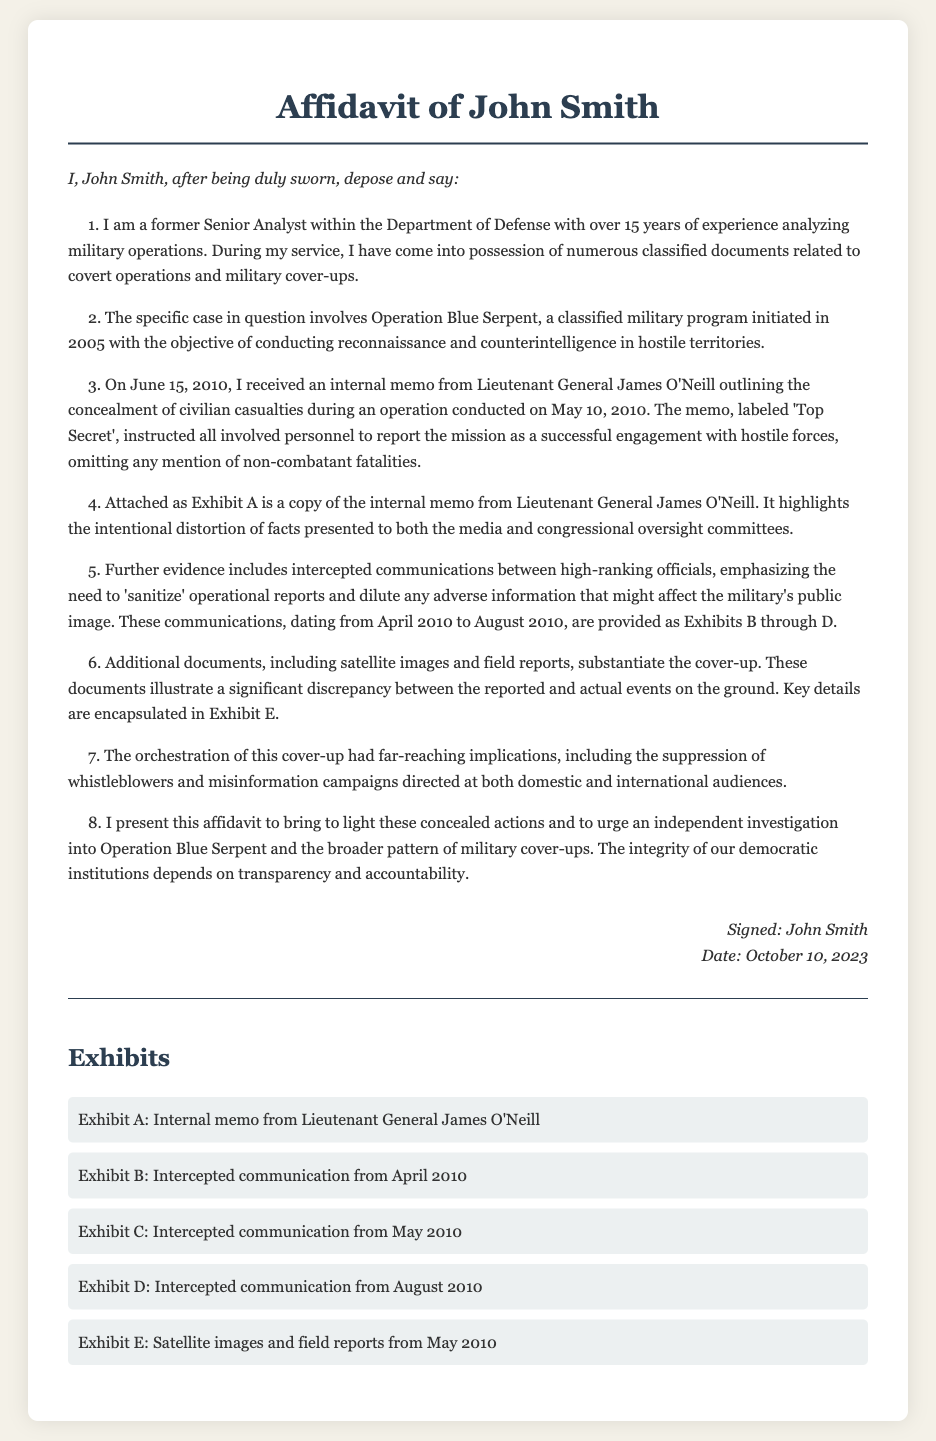What is the name of the affiant? The name of the affiant is mentioned at the beginning of the affidavit.
Answer: John Smith How many years of experience does John Smith have? The affidavit states the number of years of experience he has in military operations.
Answer: 15 years What is the title of the classified military program? The affidavit lists the title of the military program involved in the cover-up.
Answer: Operation Blue Serpent What date was the memo from Lieutenant General James O'Neill received? The affidavit specifies the date when the affiant received the internal memo addressing the cover-up.
Answer: June 15, 2010 What was the main instruction in the internal memo? The affidavit describes a critical instruction outlined in the internal memo regarding reporting the mission.
Answer: Omit any mention of non-combatant fatalities How many exhibits are attached to the affidavit? The exhibits section details the number of documents provided as evidence of the cover-up.
Answer: Five Which type of official communication underscores the need to 'sanitize' operational reports? The affidavit indicates the type of communication that emphasized the sanitization of reports.
Answer: Intercepted communications What are the implications mentioned in the document regarding the cover-up? The affidavit discusses broader consequences resulting from the military's actions related to the cover-up.
Answer: Suppression of whistleblowers On what date was the affidavit signed? The affidavit provides the specific date when John Smith signed the document.
Answer: October 10, 2023 What is the objective of Operation Blue Serpent? The affidavit explains the objective of the classified military operation discussed.
Answer: Conducting reconnaissance and counterintelligence 